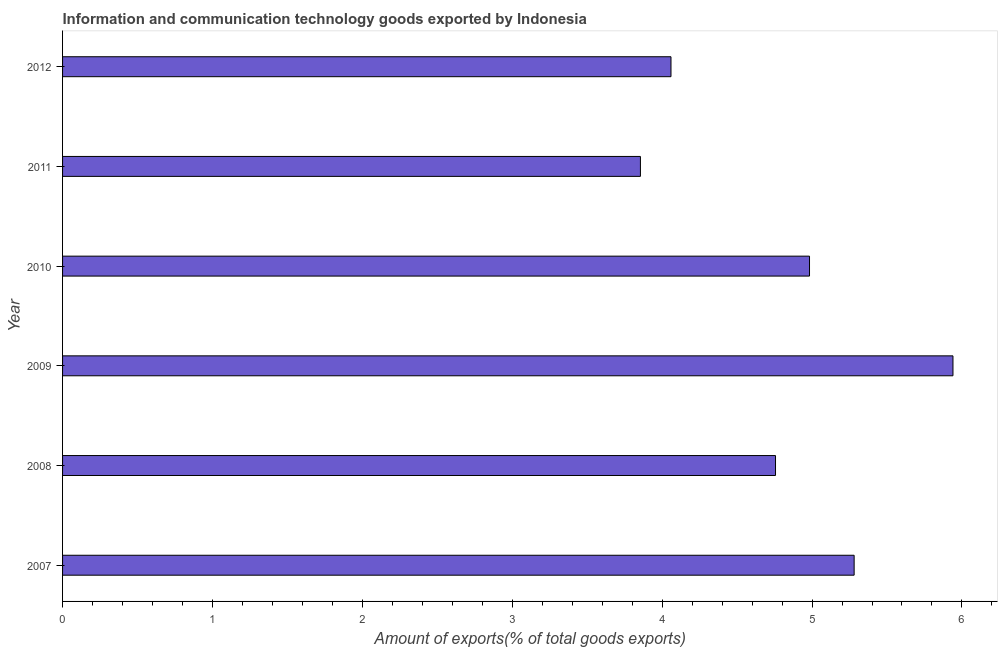What is the title of the graph?
Provide a succinct answer. Information and communication technology goods exported by Indonesia. What is the label or title of the X-axis?
Keep it short and to the point. Amount of exports(% of total goods exports). What is the label or title of the Y-axis?
Your answer should be compact. Year. What is the amount of ict goods exports in 2009?
Your answer should be very brief. 5.94. Across all years, what is the maximum amount of ict goods exports?
Your answer should be compact. 5.94. Across all years, what is the minimum amount of ict goods exports?
Provide a short and direct response. 3.86. In which year was the amount of ict goods exports maximum?
Your response must be concise. 2009. In which year was the amount of ict goods exports minimum?
Keep it short and to the point. 2011. What is the sum of the amount of ict goods exports?
Your answer should be compact. 28.87. What is the difference between the amount of ict goods exports in 2007 and 2012?
Your response must be concise. 1.22. What is the average amount of ict goods exports per year?
Make the answer very short. 4.81. What is the median amount of ict goods exports?
Ensure brevity in your answer.  4.87. In how many years, is the amount of ict goods exports greater than 5 %?
Offer a very short reply. 2. What is the ratio of the amount of ict goods exports in 2007 to that in 2012?
Your answer should be very brief. 1.3. Is the amount of ict goods exports in 2008 less than that in 2011?
Provide a short and direct response. No. Is the difference between the amount of ict goods exports in 2008 and 2009 greater than the difference between any two years?
Keep it short and to the point. No. What is the difference between the highest and the second highest amount of ict goods exports?
Give a very brief answer. 0.66. Is the sum of the amount of ict goods exports in 2010 and 2012 greater than the maximum amount of ict goods exports across all years?
Make the answer very short. Yes. What is the difference between the highest and the lowest amount of ict goods exports?
Ensure brevity in your answer.  2.09. How many bars are there?
Your response must be concise. 6. How many years are there in the graph?
Offer a very short reply. 6. What is the difference between two consecutive major ticks on the X-axis?
Give a very brief answer. 1. Are the values on the major ticks of X-axis written in scientific E-notation?
Make the answer very short. No. What is the Amount of exports(% of total goods exports) in 2007?
Offer a very short reply. 5.28. What is the Amount of exports(% of total goods exports) in 2008?
Ensure brevity in your answer.  4.76. What is the Amount of exports(% of total goods exports) of 2009?
Your answer should be compact. 5.94. What is the Amount of exports(% of total goods exports) in 2010?
Give a very brief answer. 4.98. What is the Amount of exports(% of total goods exports) in 2011?
Your answer should be very brief. 3.86. What is the Amount of exports(% of total goods exports) of 2012?
Make the answer very short. 4.06. What is the difference between the Amount of exports(% of total goods exports) in 2007 and 2008?
Keep it short and to the point. 0.52. What is the difference between the Amount of exports(% of total goods exports) in 2007 and 2009?
Keep it short and to the point. -0.66. What is the difference between the Amount of exports(% of total goods exports) in 2007 and 2010?
Offer a very short reply. 0.3. What is the difference between the Amount of exports(% of total goods exports) in 2007 and 2011?
Your response must be concise. 1.43. What is the difference between the Amount of exports(% of total goods exports) in 2007 and 2012?
Your answer should be very brief. 1.22. What is the difference between the Amount of exports(% of total goods exports) in 2008 and 2009?
Your response must be concise. -1.18. What is the difference between the Amount of exports(% of total goods exports) in 2008 and 2010?
Make the answer very short. -0.23. What is the difference between the Amount of exports(% of total goods exports) in 2008 and 2011?
Make the answer very short. 0.9. What is the difference between the Amount of exports(% of total goods exports) in 2008 and 2012?
Give a very brief answer. 0.7. What is the difference between the Amount of exports(% of total goods exports) in 2009 and 2010?
Give a very brief answer. 0.96. What is the difference between the Amount of exports(% of total goods exports) in 2009 and 2011?
Ensure brevity in your answer.  2.09. What is the difference between the Amount of exports(% of total goods exports) in 2009 and 2012?
Your response must be concise. 1.88. What is the difference between the Amount of exports(% of total goods exports) in 2010 and 2011?
Offer a terse response. 1.13. What is the difference between the Amount of exports(% of total goods exports) in 2010 and 2012?
Your answer should be compact. 0.92. What is the difference between the Amount of exports(% of total goods exports) in 2011 and 2012?
Offer a terse response. -0.2. What is the ratio of the Amount of exports(% of total goods exports) in 2007 to that in 2008?
Your answer should be very brief. 1.11. What is the ratio of the Amount of exports(% of total goods exports) in 2007 to that in 2009?
Your response must be concise. 0.89. What is the ratio of the Amount of exports(% of total goods exports) in 2007 to that in 2010?
Your response must be concise. 1.06. What is the ratio of the Amount of exports(% of total goods exports) in 2007 to that in 2011?
Offer a terse response. 1.37. What is the ratio of the Amount of exports(% of total goods exports) in 2007 to that in 2012?
Offer a terse response. 1.3. What is the ratio of the Amount of exports(% of total goods exports) in 2008 to that in 2009?
Your response must be concise. 0.8. What is the ratio of the Amount of exports(% of total goods exports) in 2008 to that in 2010?
Provide a short and direct response. 0.95. What is the ratio of the Amount of exports(% of total goods exports) in 2008 to that in 2011?
Provide a succinct answer. 1.23. What is the ratio of the Amount of exports(% of total goods exports) in 2008 to that in 2012?
Your answer should be very brief. 1.17. What is the ratio of the Amount of exports(% of total goods exports) in 2009 to that in 2010?
Provide a succinct answer. 1.19. What is the ratio of the Amount of exports(% of total goods exports) in 2009 to that in 2011?
Make the answer very short. 1.54. What is the ratio of the Amount of exports(% of total goods exports) in 2009 to that in 2012?
Keep it short and to the point. 1.46. What is the ratio of the Amount of exports(% of total goods exports) in 2010 to that in 2011?
Ensure brevity in your answer.  1.29. What is the ratio of the Amount of exports(% of total goods exports) in 2010 to that in 2012?
Give a very brief answer. 1.23. 